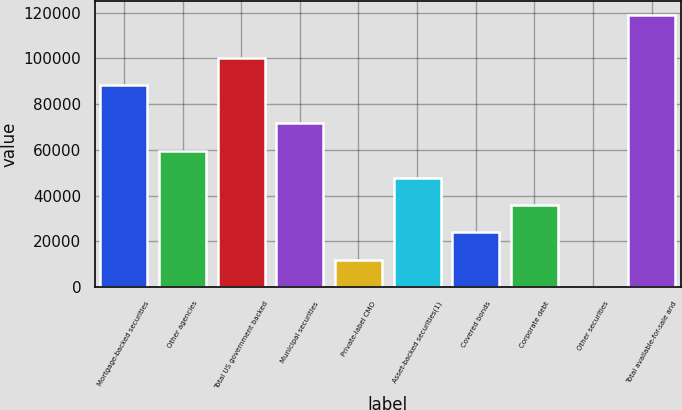Convert chart to OTSL. <chart><loc_0><loc_0><loc_500><loc_500><bar_chart><fcel>Mortgage-backed securities<fcel>Other agencies<fcel>Total US government backed<fcel>Municipal securities<fcel>Private-label CMO<fcel>Asset-backed securities(1)<fcel>Covered bonds<fcel>Corporate debt<fcel>Other securities<fcel>Total available-for-sale and<nl><fcel>88266<fcel>59679.5<fcel>100158<fcel>71571.6<fcel>12111.1<fcel>47787.4<fcel>24003.2<fcel>35895.3<fcel>219<fcel>119140<nl></chart> 